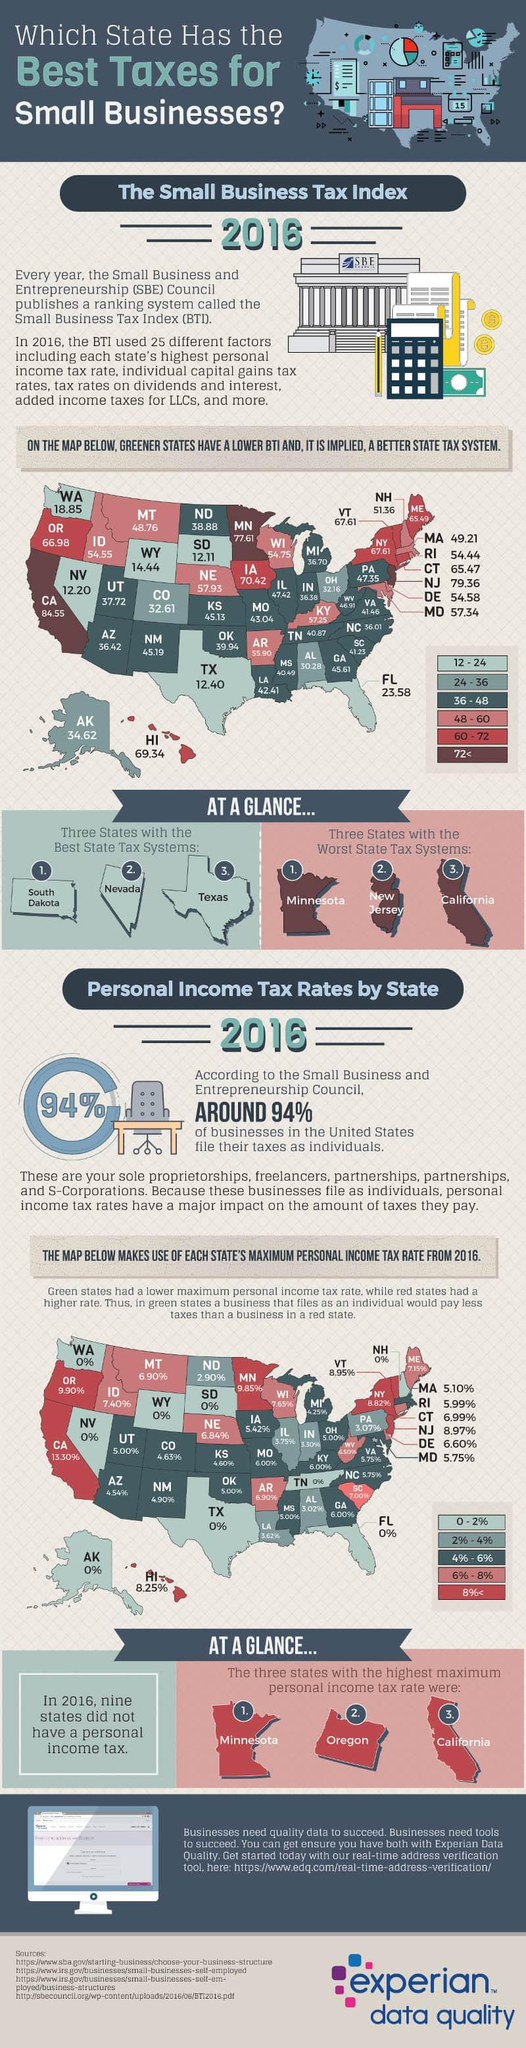Mention a couple of crucial points in this snapshot. In the year 2016, the maximum personal income tax rate in the state of Hawaii was 8.25%. The business tax index of Texas in 2016 was 12.40. California had the highest Business Tax Index in the Western United States in 2016. The maximum personal income tax rate in the state of New Mexico in 2016 was 4.90%. In 2016, California had the worst state tax system among all U.S. states, except for Minnesota and New Jersey. 